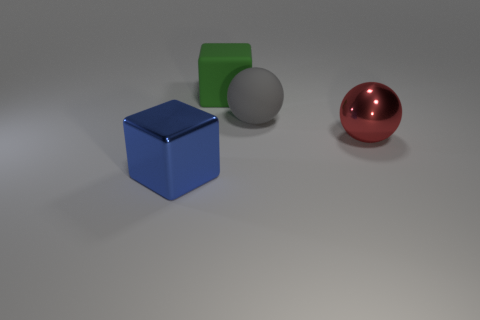Add 2 purple objects. How many objects exist? 6 Add 2 small red metal balls. How many small red metal balls exist? 2 Subtract 0 yellow cubes. How many objects are left? 4 Subtract all cubes. Subtract all gray matte things. How many objects are left? 1 Add 4 green cubes. How many green cubes are left? 5 